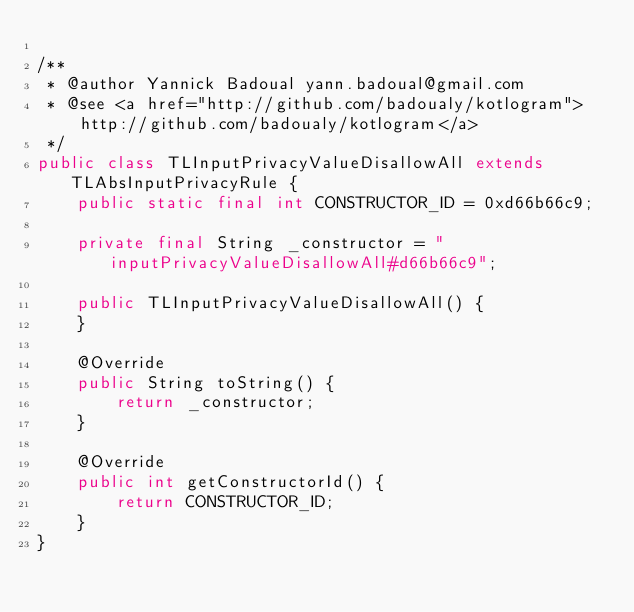<code> <loc_0><loc_0><loc_500><loc_500><_Java_>
/**
 * @author Yannick Badoual yann.badoual@gmail.com
 * @see <a href="http://github.com/badoualy/kotlogram">http://github.com/badoualy/kotlogram</a>
 */
public class TLInputPrivacyValueDisallowAll extends TLAbsInputPrivacyRule {
    public static final int CONSTRUCTOR_ID = 0xd66b66c9;

    private final String _constructor = "inputPrivacyValueDisallowAll#d66b66c9";

    public TLInputPrivacyValueDisallowAll() {
    }

    @Override
    public String toString() {
        return _constructor;
    }

    @Override
    public int getConstructorId() {
        return CONSTRUCTOR_ID;
    }
}
</code> 